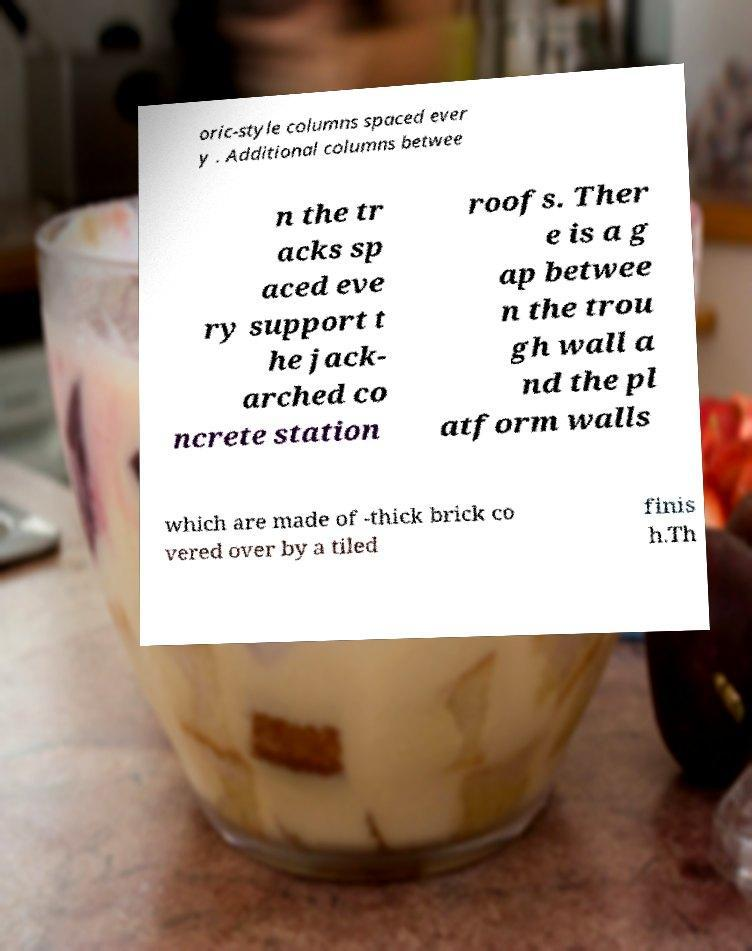There's text embedded in this image that I need extracted. Can you transcribe it verbatim? oric-style columns spaced ever y . Additional columns betwee n the tr acks sp aced eve ry support t he jack- arched co ncrete station roofs. Ther e is a g ap betwee n the trou gh wall a nd the pl atform walls which are made of -thick brick co vered over by a tiled finis h.Th 